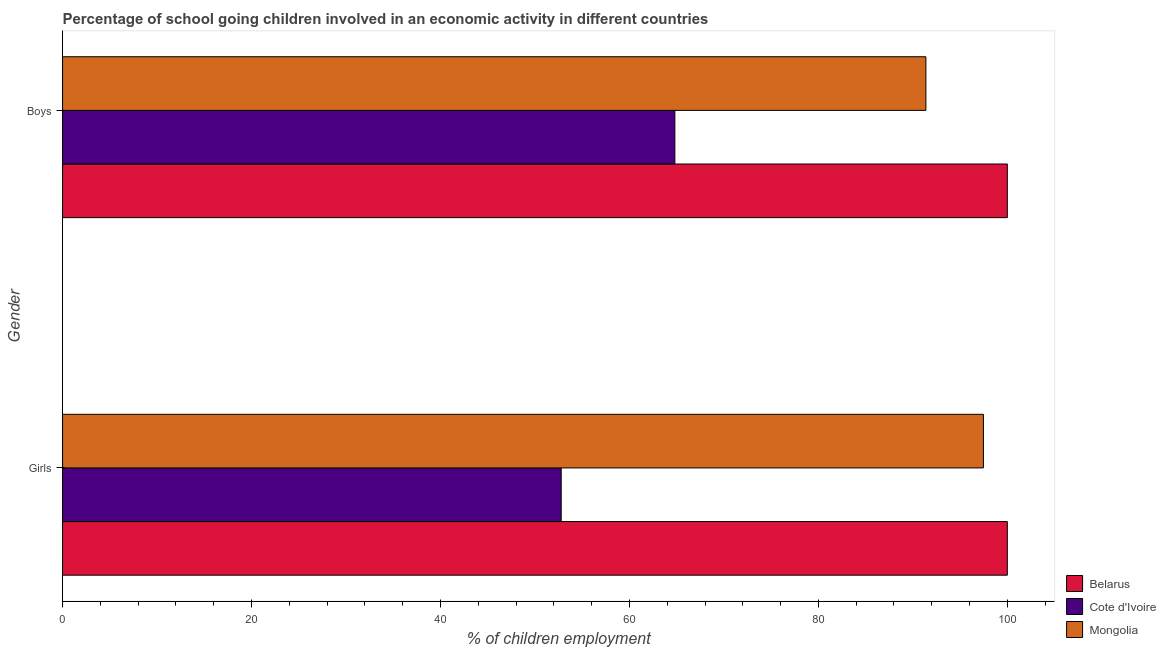Are the number of bars per tick equal to the number of legend labels?
Make the answer very short. Yes. Are the number of bars on each tick of the Y-axis equal?
Offer a terse response. Yes. How many bars are there on the 2nd tick from the top?
Your answer should be compact. 3. What is the label of the 2nd group of bars from the top?
Keep it short and to the point. Girls. What is the percentage of school going boys in Mongolia?
Offer a very short reply. 91.38. Across all countries, what is the minimum percentage of school going boys?
Your answer should be very brief. 64.81. In which country was the percentage of school going girls maximum?
Ensure brevity in your answer.  Belarus. In which country was the percentage of school going boys minimum?
Offer a terse response. Cote d'Ivoire. What is the total percentage of school going boys in the graph?
Keep it short and to the point. 256.19. What is the difference between the percentage of school going girls in Mongolia and that in Belarus?
Your answer should be very brief. -2.53. What is the difference between the percentage of school going boys in Mongolia and the percentage of school going girls in Belarus?
Provide a short and direct response. -8.62. What is the average percentage of school going girls per country?
Offer a terse response. 83.42. What is the difference between the percentage of school going boys and percentage of school going girls in Cote d'Ivoire?
Provide a succinct answer. 12.03. In how many countries, is the percentage of school going girls greater than 88 %?
Ensure brevity in your answer.  2. What is the ratio of the percentage of school going boys in Belarus to that in Mongolia?
Ensure brevity in your answer.  1.09. Is the percentage of school going girls in Mongolia less than that in Belarus?
Your answer should be compact. Yes. In how many countries, is the percentage of school going girls greater than the average percentage of school going girls taken over all countries?
Keep it short and to the point. 2. What does the 2nd bar from the top in Girls represents?
Offer a very short reply. Cote d'Ivoire. What does the 3rd bar from the bottom in Girls represents?
Provide a short and direct response. Mongolia. Are all the bars in the graph horizontal?
Keep it short and to the point. Yes. What is the title of the graph?
Your response must be concise. Percentage of school going children involved in an economic activity in different countries. Does "Fiji" appear as one of the legend labels in the graph?
Your answer should be very brief. No. What is the label or title of the X-axis?
Keep it short and to the point. % of children employment. What is the label or title of the Y-axis?
Your response must be concise. Gender. What is the % of children employment of Belarus in Girls?
Your answer should be very brief. 100. What is the % of children employment of Cote d'Ivoire in Girls?
Keep it short and to the point. 52.78. What is the % of children employment of Mongolia in Girls?
Keep it short and to the point. 97.47. What is the % of children employment in Belarus in Boys?
Provide a succinct answer. 100. What is the % of children employment in Cote d'Ivoire in Boys?
Your answer should be compact. 64.81. What is the % of children employment of Mongolia in Boys?
Your response must be concise. 91.38. Across all Gender, what is the maximum % of children employment in Cote d'Ivoire?
Keep it short and to the point. 64.81. Across all Gender, what is the maximum % of children employment in Mongolia?
Ensure brevity in your answer.  97.47. Across all Gender, what is the minimum % of children employment of Belarus?
Your response must be concise. 100. Across all Gender, what is the minimum % of children employment of Cote d'Ivoire?
Ensure brevity in your answer.  52.78. Across all Gender, what is the minimum % of children employment in Mongolia?
Ensure brevity in your answer.  91.38. What is the total % of children employment in Cote d'Ivoire in the graph?
Keep it short and to the point. 117.59. What is the total % of children employment in Mongolia in the graph?
Provide a short and direct response. 188.85. What is the difference between the % of children employment of Belarus in Girls and that in Boys?
Your answer should be very brief. 0. What is the difference between the % of children employment in Cote d'Ivoire in Girls and that in Boys?
Offer a very short reply. -12.03. What is the difference between the % of children employment of Mongolia in Girls and that in Boys?
Your response must be concise. 6.09. What is the difference between the % of children employment of Belarus in Girls and the % of children employment of Cote d'Ivoire in Boys?
Offer a very short reply. 35.19. What is the difference between the % of children employment of Belarus in Girls and the % of children employment of Mongolia in Boys?
Provide a succinct answer. 8.62. What is the difference between the % of children employment of Cote d'Ivoire in Girls and the % of children employment of Mongolia in Boys?
Your answer should be very brief. -38.6. What is the average % of children employment in Belarus per Gender?
Keep it short and to the point. 100. What is the average % of children employment of Cote d'Ivoire per Gender?
Your response must be concise. 58.79. What is the average % of children employment in Mongolia per Gender?
Your answer should be compact. 94.42. What is the difference between the % of children employment of Belarus and % of children employment of Cote d'Ivoire in Girls?
Offer a terse response. 47.22. What is the difference between the % of children employment of Belarus and % of children employment of Mongolia in Girls?
Provide a short and direct response. 2.53. What is the difference between the % of children employment of Cote d'Ivoire and % of children employment of Mongolia in Girls?
Your response must be concise. -44.69. What is the difference between the % of children employment in Belarus and % of children employment in Cote d'Ivoire in Boys?
Make the answer very short. 35.19. What is the difference between the % of children employment of Belarus and % of children employment of Mongolia in Boys?
Make the answer very short. 8.62. What is the difference between the % of children employment of Cote d'Ivoire and % of children employment of Mongolia in Boys?
Give a very brief answer. -26.57. What is the ratio of the % of children employment of Cote d'Ivoire in Girls to that in Boys?
Ensure brevity in your answer.  0.81. What is the ratio of the % of children employment in Mongolia in Girls to that in Boys?
Offer a very short reply. 1.07. What is the difference between the highest and the second highest % of children employment in Belarus?
Provide a succinct answer. 0. What is the difference between the highest and the second highest % of children employment of Cote d'Ivoire?
Give a very brief answer. 12.03. What is the difference between the highest and the second highest % of children employment in Mongolia?
Offer a very short reply. 6.09. What is the difference between the highest and the lowest % of children employment in Cote d'Ivoire?
Keep it short and to the point. 12.03. What is the difference between the highest and the lowest % of children employment of Mongolia?
Provide a short and direct response. 6.09. 